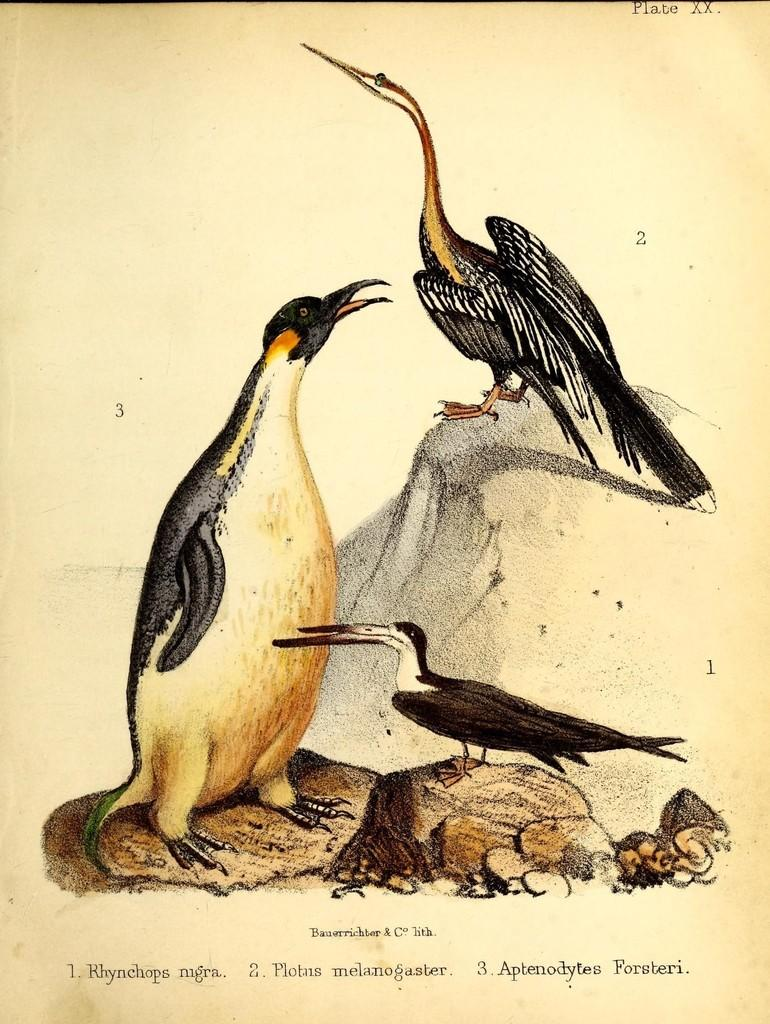What is the main subject of the image? The image contains a painting. What types of animals are included in the painting? The painting includes birds. What other elements are present in the painting? The painting includes rocks. Is there any text associated with the painting? Yes, there is written text at the bottom of the painting. How many beds are visible in the painting? There are no beds present in the painting; it features birds and rocks. Is there a camp visible in the painting? There is no camp present in the painting; it features birds and rocks. 